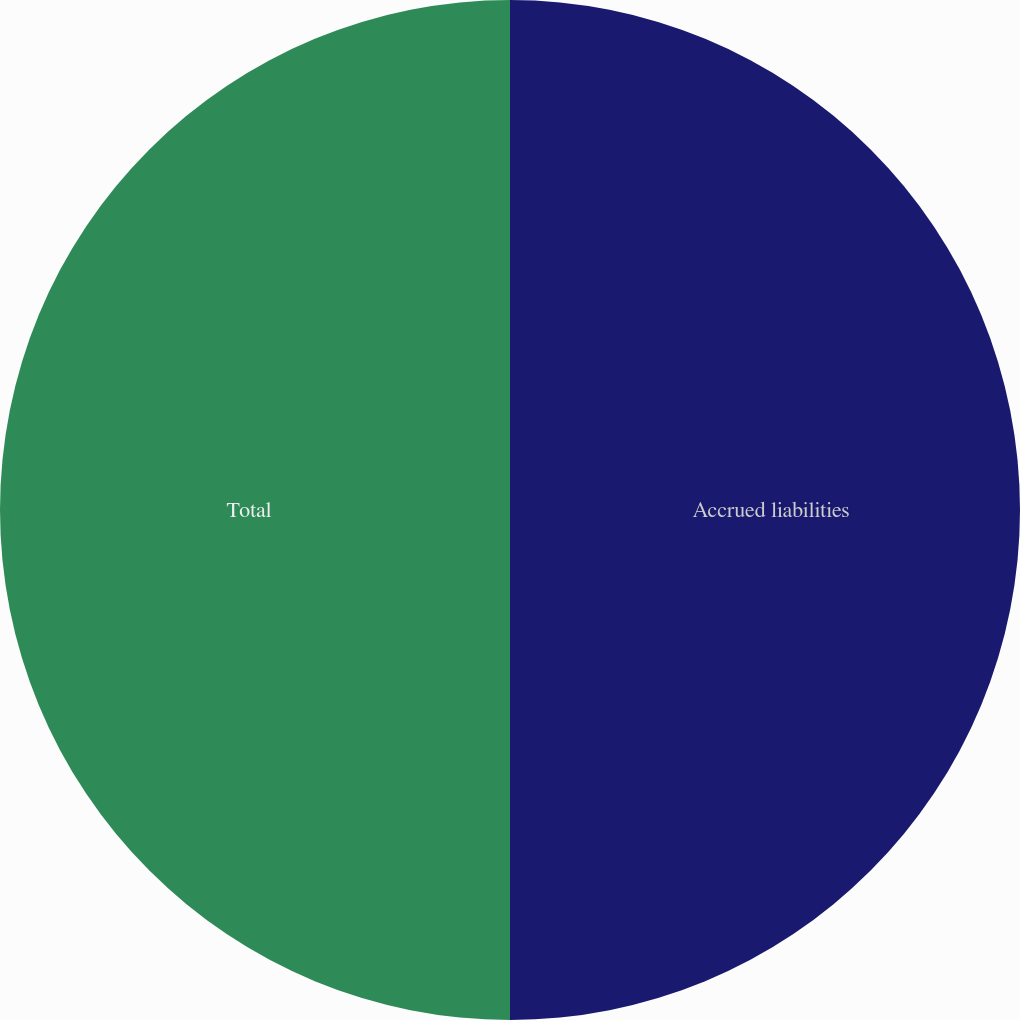<chart> <loc_0><loc_0><loc_500><loc_500><pie_chart><fcel>Accrued liabilities<fcel>Total<nl><fcel>50.0%<fcel>50.0%<nl></chart> 